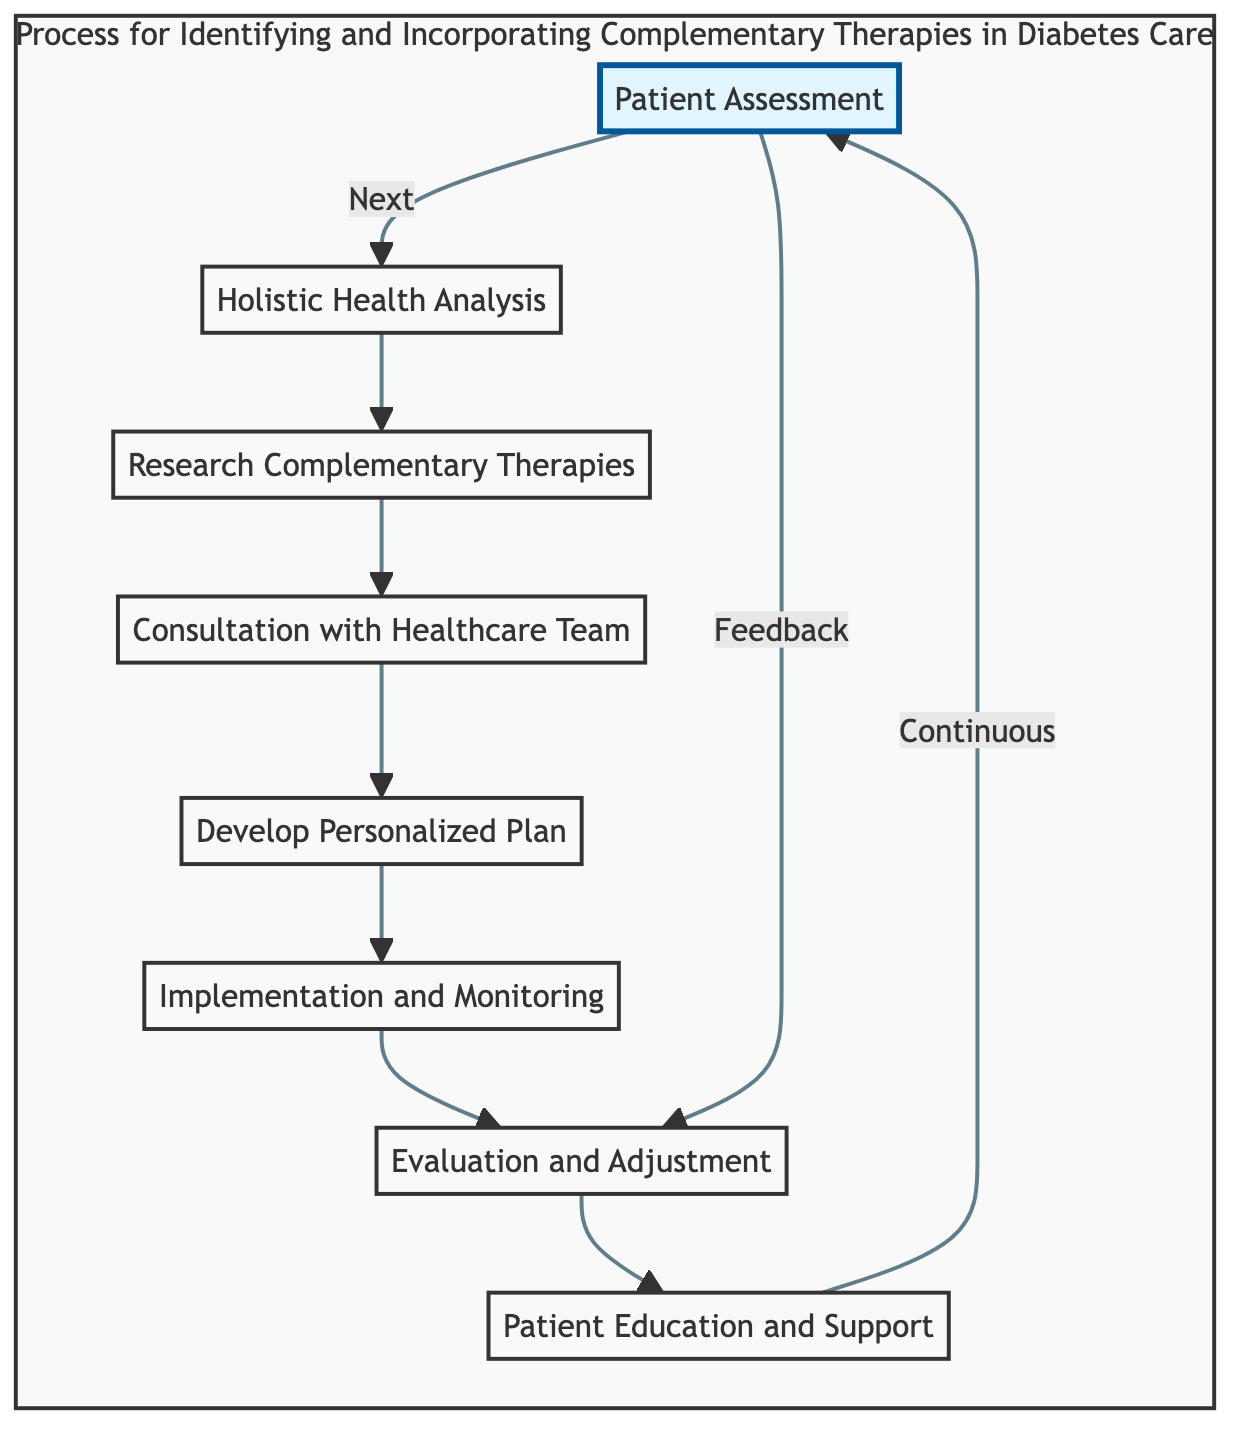What is the first step in the process? The first step identified in the flowchart is "Patient Assessment," which is the starting point of the entire process.
Answer: Patient Assessment How many steps are in the process? By counting the individual steps represented in the flowchart, it totals to eight distinct nodes, from "Patient Assessment" to "Patient Education and Support."
Answer: 8 Which step comes after "Research Complementary Therapies"? According to the flowchart structure, the node that follows "Research Complementary Therapies" is "Consultation with Healthcare Team."
Answer: Consultation with Healthcare Team What action occurs after "Implementation and Monitoring"? The flowchart indicates that the next step after "Implementation and Monitoring" is "Evaluation and Adjustment."
Answer: Evaluation and Adjustment What relationship does "Patient Education and Support" have with "Patient Assessment"? The flowchart shows a feedback loop where "Patient Education and Support" connects back to "Patient Assessment," indicating a continuous cycle of care.
Answer: Continuous Which step involves educating the patient? The step that specifically focuses on educating the patient is "Patient Education and Support."
Answer: Patient Education and Support What is required before developing a personalized plan? Before creating a personalized plan, the flowchart highlights that "Consultation with Healthcare Team" must occur, integrating information from previous steps.
Answer: Consultation with Healthcare Team What aspect does "Holistic Health Analysis" assess? The flowchart specifies that "Holistic Health Analysis" evaluates lifestyle factors including diet, physical activity, sleep patterns, stress levels, and emotional well-being.
Answer: Lifestyle factors What happens if the patient provides feedback? The flowchart shows that feedback from the patient leads back to "Evaluation and Adjustment," allowing for modifications in the treatment process.
Answer: Evaluation and Adjustment 